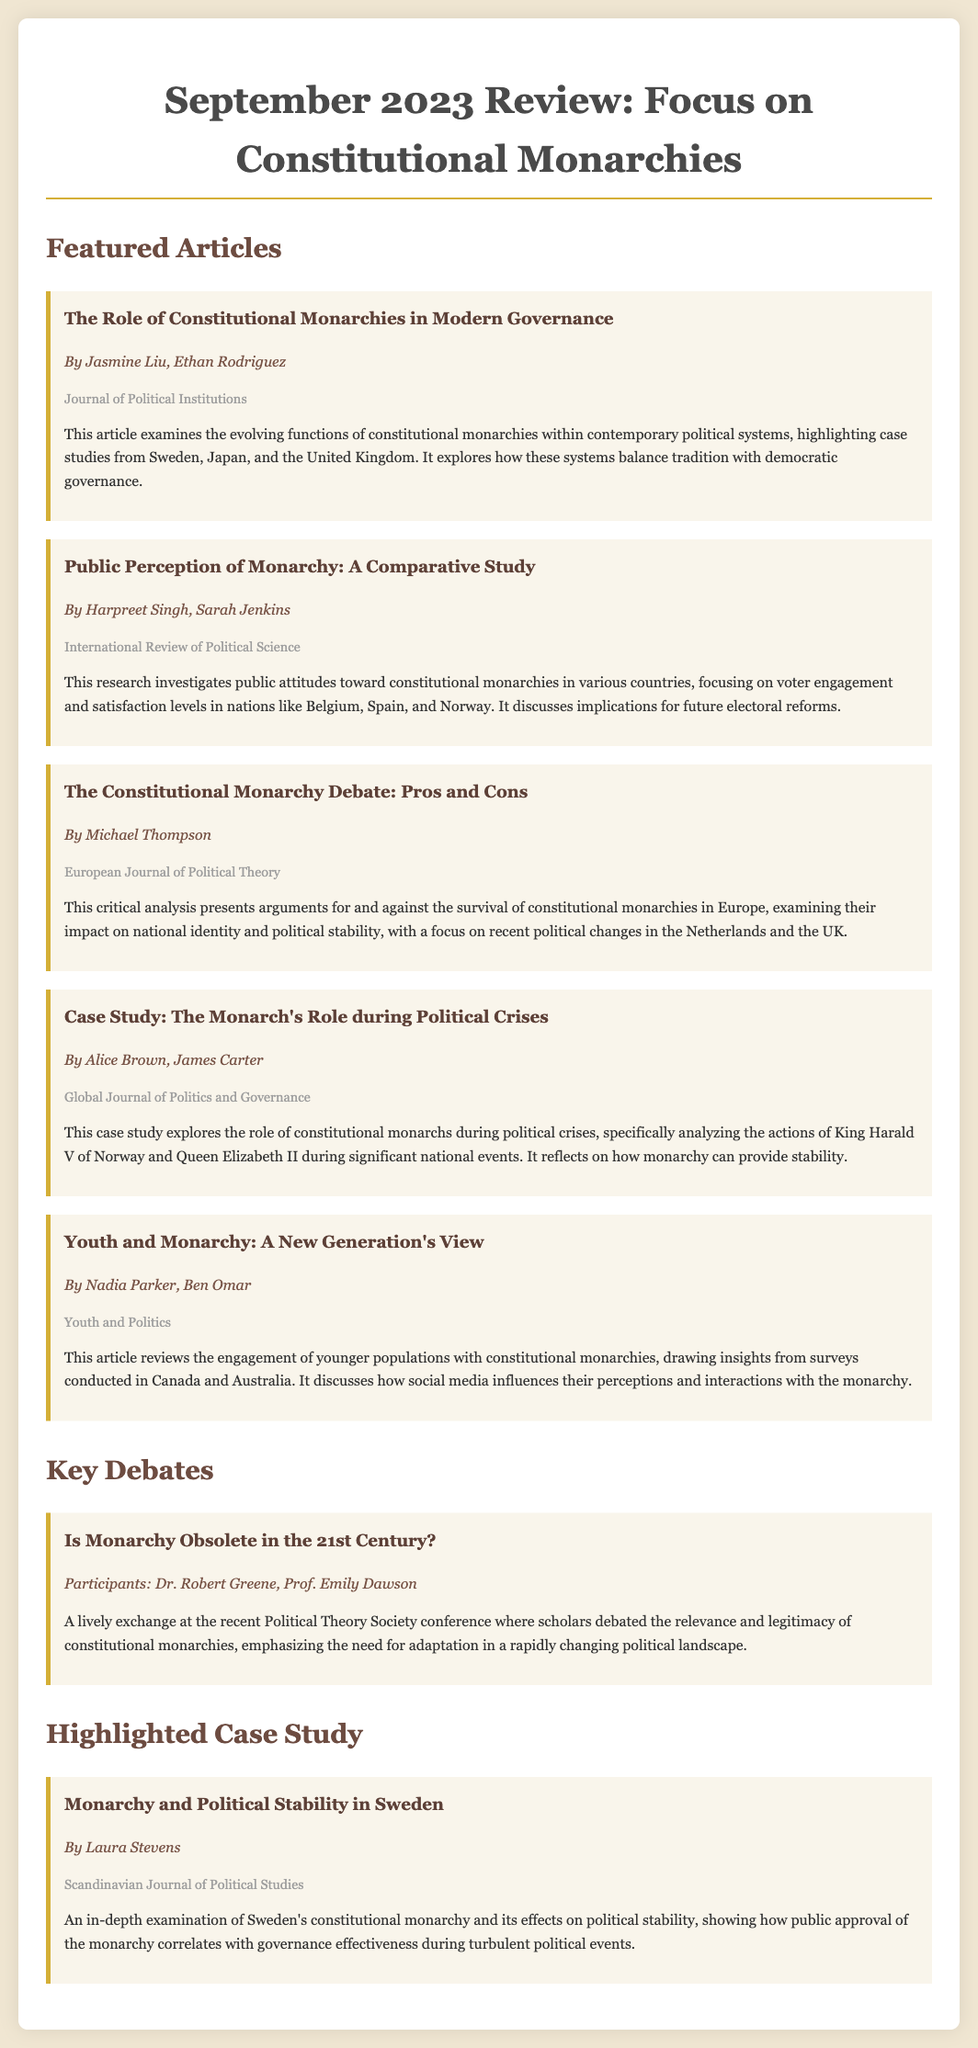What is the title of the featured article about modern governance? The title is listed in the "Featured Articles" section within the document, and it is "The Role of Constitutional Monarchies in Modern Governance."
Answer: The Role of Constitutional Monarchies in Modern Governance Who authored the article on public perception of monarchy? The authors are mentioned just below the title in the respective article's summary, which is "Public Perception of Monarchy: A Comparative Study."
Answer: Harpreet Singh, Sarah Jenkins Which journal published the article about the constitutional monarchy debate? The journal is noted at the end of the article summary, and it is mentioned for “The Constitutional Monarchy Debate: Pros and Cons.”
Answer: European Journal of Political Theory What case study focuses on the monarch's role during political crises? The case study title is present under the "Featured Articles" section and specifically analyzes the role of monarchs during political crises.
Answer: Case Study: The Monarch's Role during Political Crises What is a key topic covered in the debate titled "Is Monarchy Obsolete in the 21st Century?" This debate discusses the relevance and legitimacy of constitutional monarchies in modern times, as outlined in the summary of the document.
Answer: Relevance and legitimacy Who authored the highlighted case study on monarchy and political stability in Sweden? The author’s name appears below the title of the case study "Monarchy and Political Stability in Sweden" in the document.
Answer: Laura Stevens From which journal does the case study on Sweden's monarchy come? The journal is listed in the summary of the highlighted case study, confirming where it was published.
Answer: Scandinavian Journal of Political Studies What is the primary focus of the article "Youth and Monarchy: A New Generation's View"? The article's summary indicates that it centers around how younger populations engage with constitutional monarchies and their perceptions.
Answer: Youth engagement with monarchy 